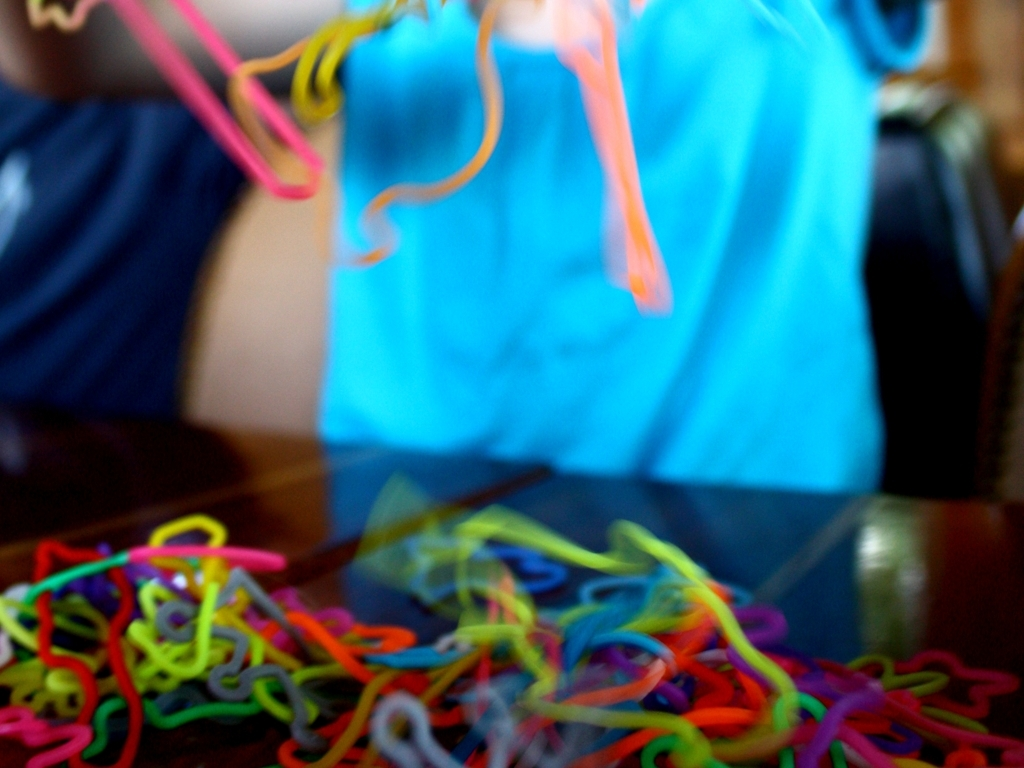Is the image sharp? The image is not sharp; it displays a deliberate use of selective focus where only a small portion of the colorful objects is in focus, creating a blurred effect that can convey movement or emphasize the vividness of the elements that are in focus. 